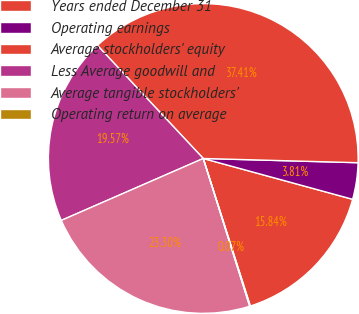Convert chart. <chart><loc_0><loc_0><loc_500><loc_500><pie_chart><fcel>Years ended December 31<fcel>Operating earnings<fcel>Average stockholders' equity<fcel>Less Average goodwill and<fcel>Average tangible stockholders'<fcel>Operating return on average<nl><fcel>15.84%<fcel>3.81%<fcel>37.41%<fcel>19.57%<fcel>23.3%<fcel>0.07%<nl></chart> 